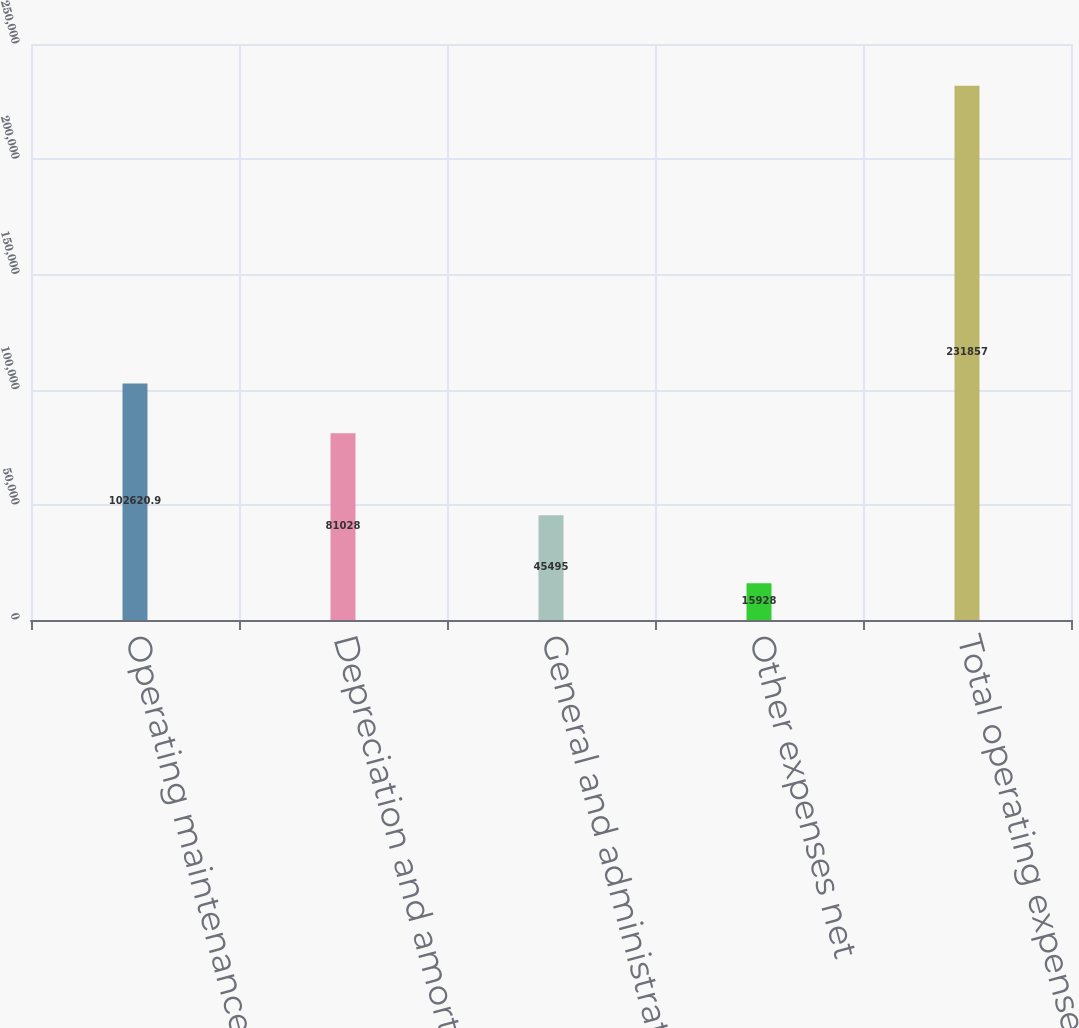Convert chart to OTSL. <chart><loc_0><loc_0><loc_500><loc_500><bar_chart><fcel>Operating maintenance and real<fcel>Depreciation and amortization<fcel>General and administrative<fcel>Other expenses net<fcel>Total operating expenses<nl><fcel>102621<fcel>81028<fcel>45495<fcel>15928<fcel>231857<nl></chart> 